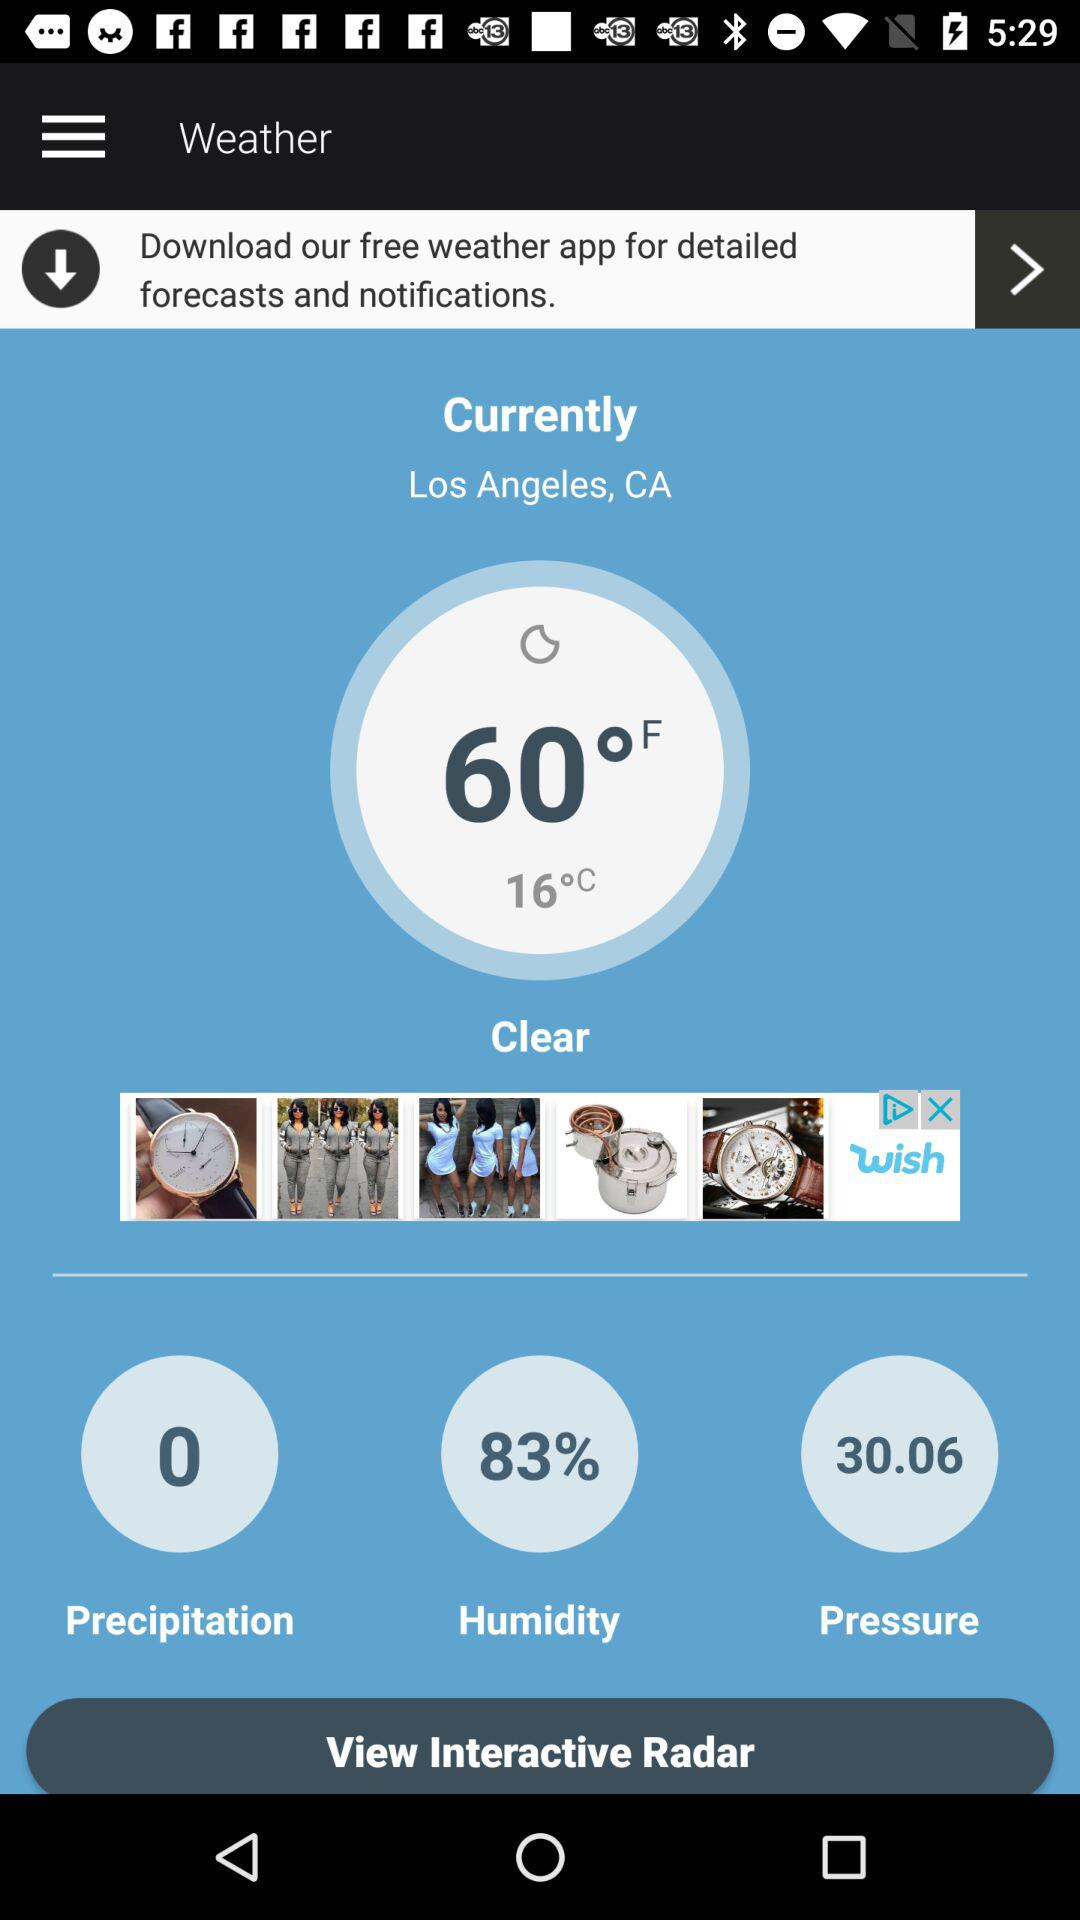What is the location given on the screen? The given location is Los Angeles, CA. 